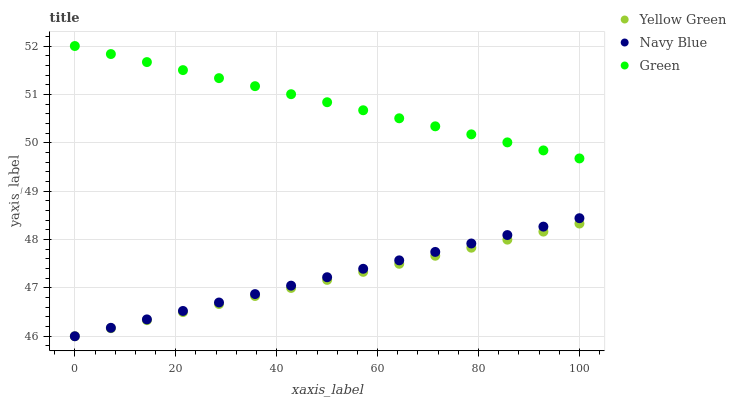Does Yellow Green have the minimum area under the curve?
Answer yes or no. Yes. Does Green have the maximum area under the curve?
Answer yes or no. Yes. Does Green have the minimum area under the curve?
Answer yes or no. No. Does Yellow Green have the maximum area under the curve?
Answer yes or no. No. Is Yellow Green the smoothest?
Answer yes or no. Yes. Is Green the roughest?
Answer yes or no. Yes. Is Green the smoothest?
Answer yes or no. No. Is Yellow Green the roughest?
Answer yes or no. No. Does Navy Blue have the lowest value?
Answer yes or no. Yes. Does Green have the lowest value?
Answer yes or no. No. Does Green have the highest value?
Answer yes or no. Yes. Does Yellow Green have the highest value?
Answer yes or no. No. Is Navy Blue less than Green?
Answer yes or no. Yes. Is Green greater than Yellow Green?
Answer yes or no. Yes. Does Navy Blue intersect Yellow Green?
Answer yes or no. Yes. Is Navy Blue less than Yellow Green?
Answer yes or no. No. Is Navy Blue greater than Yellow Green?
Answer yes or no. No. Does Navy Blue intersect Green?
Answer yes or no. No. 